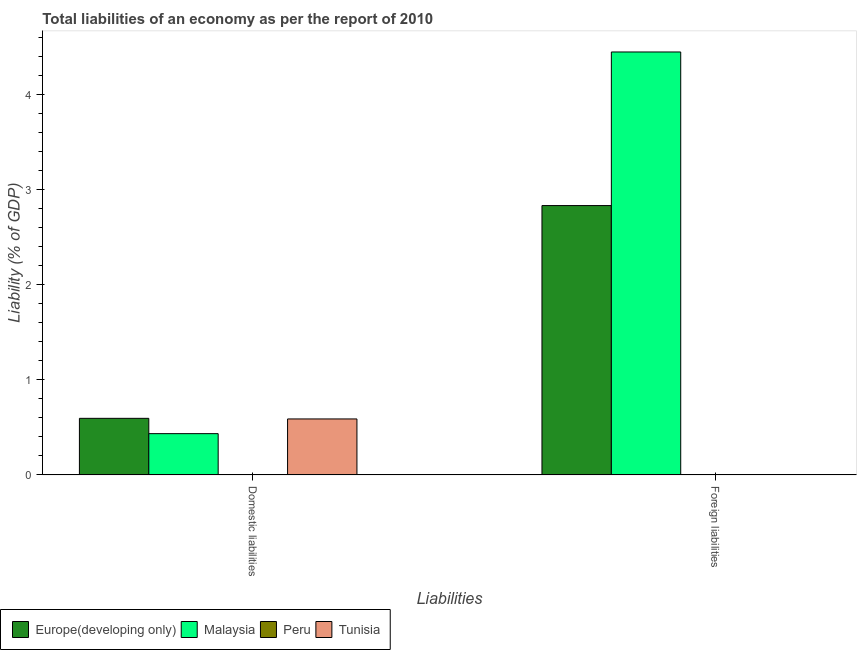How many different coloured bars are there?
Your response must be concise. 3. Are the number of bars on each tick of the X-axis equal?
Your response must be concise. No. How many bars are there on the 1st tick from the right?
Your response must be concise. 2. What is the label of the 2nd group of bars from the left?
Your answer should be very brief. Foreign liabilities. What is the incurrence of domestic liabilities in Peru?
Provide a short and direct response. 0. Across all countries, what is the maximum incurrence of foreign liabilities?
Your answer should be very brief. 4.45. In which country was the incurrence of foreign liabilities maximum?
Your answer should be very brief. Malaysia. What is the total incurrence of foreign liabilities in the graph?
Ensure brevity in your answer.  7.28. What is the difference between the incurrence of domestic liabilities in Malaysia and that in Tunisia?
Make the answer very short. -0.15. What is the difference between the incurrence of foreign liabilities in Malaysia and the incurrence of domestic liabilities in Peru?
Make the answer very short. 4.45. What is the average incurrence of foreign liabilities per country?
Your answer should be very brief. 1.82. What is the difference between the incurrence of domestic liabilities and incurrence of foreign liabilities in Malaysia?
Provide a short and direct response. -4.02. What is the ratio of the incurrence of foreign liabilities in Malaysia to that in Europe(developing only)?
Offer a terse response. 1.57. In how many countries, is the incurrence of foreign liabilities greater than the average incurrence of foreign liabilities taken over all countries?
Provide a short and direct response. 2. How many bars are there?
Give a very brief answer. 5. Are all the bars in the graph horizontal?
Your response must be concise. No. How many countries are there in the graph?
Give a very brief answer. 4. What is the difference between two consecutive major ticks on the Y-axis?
Give a very brief answer. 1. Does the graph contain any zero values?
Give a very brief answer. Yes. How many legend labels are there?
Keep it short and to the point. 4. How are the legend labels stacked?
Keep it short and to the point. Horizontal. What is the title of the graph?
Ensure brevity in your answer.  Total liabilities of an economy as per the report of 2010. Does "Uganda" appear as one of the legend labels in the graph?
Your answer should be very brief. No. What is the label or title of the X-axis?
Your answer should be very brief. Liabilities. What is the label or title of the Y-axis?
Offer a very short reply. Liability (% of GDP). What is the Liability (% of GDP) of Europe(developing only) in Domestic liabilities?
Your response must be concise. 0.6. What is the Liability (% of GDP) of Malaysia in Domestic liabilities?
Provide a short and direct response. 0.43. What is the Liability (% of GDP) in Tunisia in Domestic liabilities?
Provide a short and direct response. 0.59. What is the Liability (% of GDP) in Europe(developing only) in Foreign liabilities?
Offer a terse response. 2.83. What is the Liability (% of GDP) of Malaysia in Foreign liabilities?
Offer a very short reply. 4.45. Across all Liabilities, what is the maximum Liability (% of GDP) of Europe(developing only)?
Give a very brief answer. 2.83. Across all Liabilities, what is the maximum Liability (% of GDP) in Malaysia?
Provide a succinct answer. 4.45. Across all Liabilities, what is the maximum Liability (% of GDP) of Tunisia?
Provide a short and direct response. 0.59. Across all Liabilities, what is the minimum Liability (% of GDP) in Europe(developing only)?
Your answer should be very brief. 0.6. Across all Liabilities, what is the minimum Liability (% of GDP) in Malaysia?
Your response must be concise. 0.43. What is the total Liability (% of GDP) in Europe(developing only) in the graph?
Keep it short and to the point. 3.43. What is the total Liability (% of GDP) in Malaysia in the graph?
Provide a succinct answer. 4.88. What is the total Liability (% of GDP) in Tunisia in the graph?
Provide a short and direct response. 0.59. What is the difference between the Liability (% of GDP) of Europe(developing only) in Domestic liabilities and that in Foreign liabilities?
Keep it short and to the point. -2.24. What is the difference between the Liability (% of GDP) in Malaysia in Domestic liabilities and that in Foreign liabilities?
Make the answer very short. -4.02. What is the difference between the Liability (% of GDP) in Europe(developing only) in Domestic liabilities and the Liability (% of GDP) in Malaysia in Foreign liabilities?
Offer a terse response. -3.85. What is the average Liability (% of GDP) in Europe(developing only) per Liabilities?
Your answer should be very brief. 1.71. What is the average Liability (% of GDP) in Malaysia per Liabilities?
Make the answer very short. 2.44. What is the average Liability (% of GDP) of Tunisia per Liabilities?
Provide a short and direct response. 0.29. What is the difference between the Liability (% of GDP) of Europe(developing only) and Liability (% of GDP) of Malaysia in Domestic liabilities?
Your response must be concise. 0.16. What is the difference between the Liability (% of GDP) of Europe(developing only) and Liability (% of GDP) of Tunisia in Domestic liabilities?
Keep it short and to the point. 0.01. What is the difference between the Liability (% of GDP) in Malaysia and Liability (% of GDP) in Tunisia in Domestic liabilities?
Keep it short and to the point. -0.15. What is the difference between the Liability (% of GDP) of Europe(developing only) and Liability (% of GDP) of Malaysia in Foreign liabilities?
Give a very brief answer. -1.62. What is the ratio of the Liability (% of GDP) of Europe(developing only) in Domestic liabilities to that in Foreign liabilities?
Offer a very short reply. 0.21. What is the ratio of the Liability (% of GDP) of Malaysia in Domestic liabilities to that in Foreign liabilities?
Offer a terse response. 0.1. What is the difference between the highest and the second highest Liability (% of GDP) of Europe(developing only)?
Provide a short and direct response. 2.24. What is the difference between the highest and the second highest Liability (% of GDP) in Malaysia?
Your answer should be compact. 4.02. What is the difference between the highest and the lowest Liability (% of GDP) of Europe(developing only)?
Make the answer very short. 2.24. What is the difference between the highest and the lowest Liability (% of GDP) of Malaysia?
Provide a succinct answer. 4.02. What is the difference between the highest and the lowest Liability (% of GDP) of Tunisia?
Your answer should be compact. 0.59. 